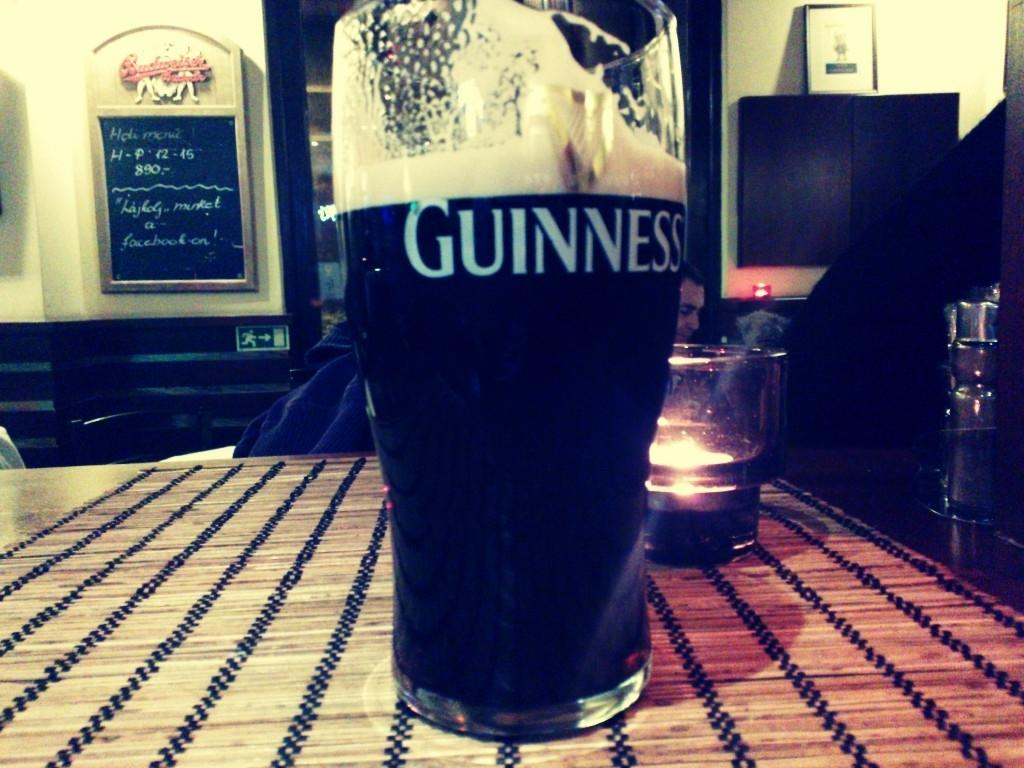Provide a one-sentence caption for the provided image. A glass of Guinness appears to have had a few sips taken out of it. 